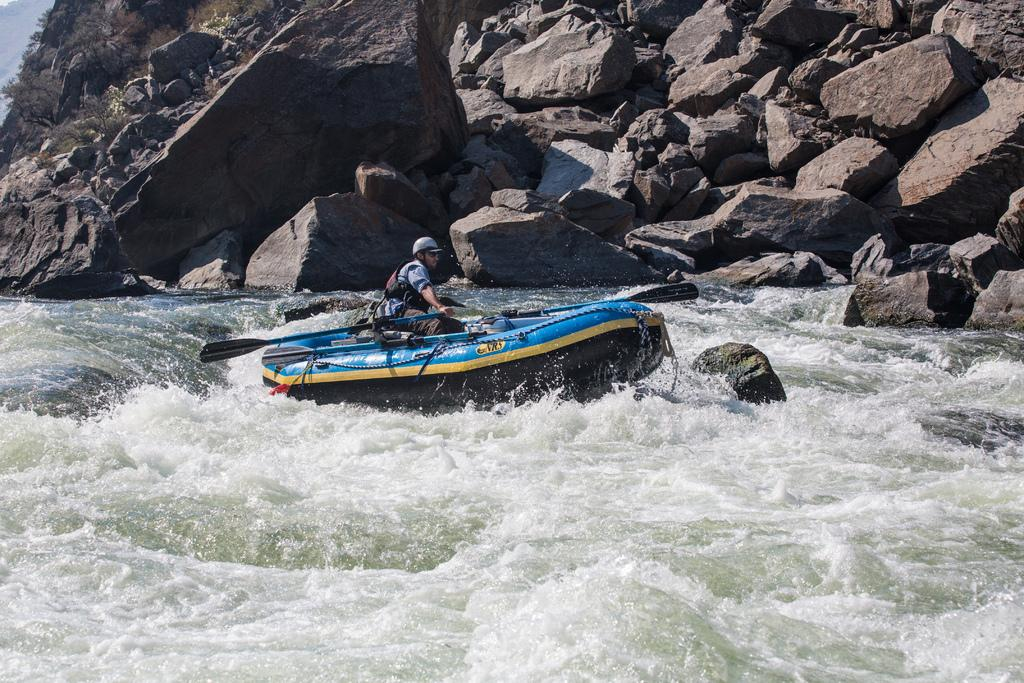What is the main subject in the center of the image? There is a boat in the center of the image. Who or what is in the boat? There is a person sitting in the boat. What is the person doing in the boat? The person is holding a paddle. What can be seen in the background of the image? There is water and hills visible in the background of the image. How many passengers are in the boat, and what are they farming in the image? There is only one person in the boat, and they are not farming in the image. The image shows a person paddling a boat in a natural setting with water and hills in the background. 